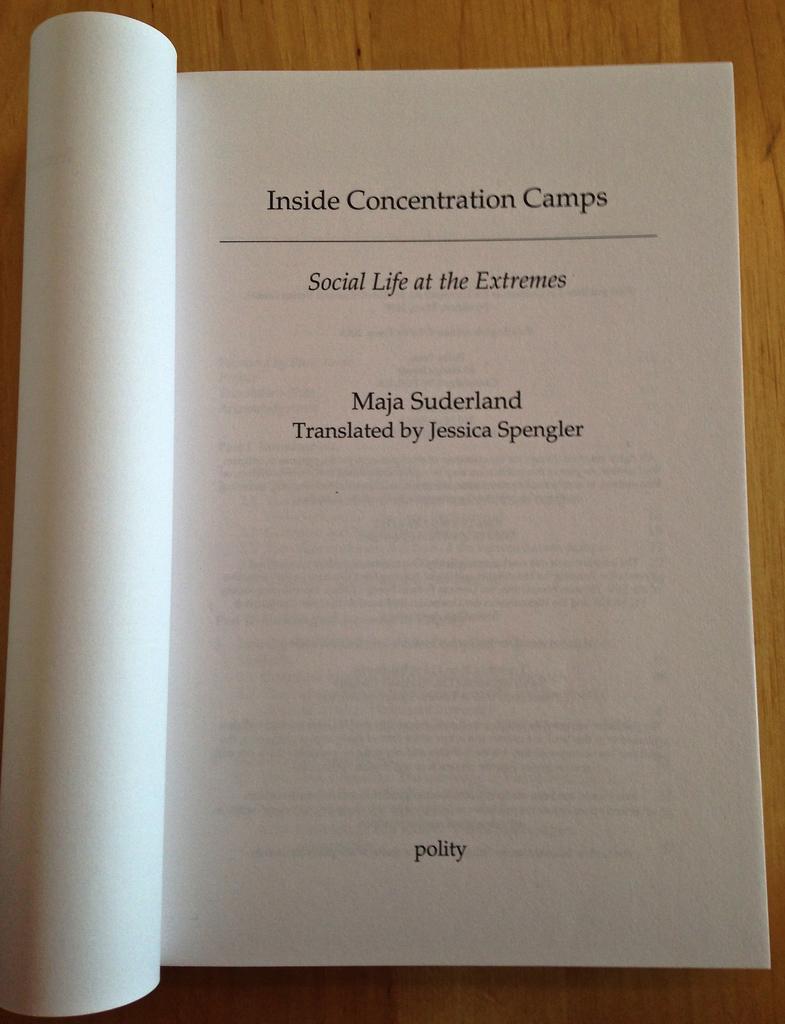What is the most recent book of maja suderland?
Offer a terse response. Inside concentration camps. What is the word in the center at the bottom?
Your response must be concise. Polity. 